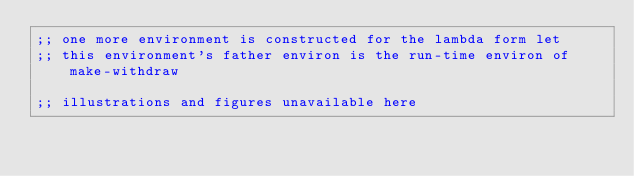Convert code to text. <code><loc_0><loc_0><loc_500><loc_500><_Scheme_>;; one more environment is constructed for the lambda form let
;; this environment's father environ is the run-time environ of make-withdraw

;; illustrations and figures unavailable here
</code> 